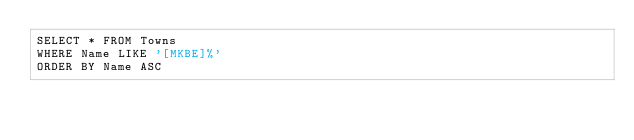Convert code to text. <code><loc_0><loc_0><loc_500><loc_500><_SQL_>SELECT * FROM Towns
WHERE Name LIKE '[MKBE]%'
ORDER BY Name ASC</code> 